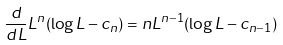<formula> <loc_0><loc_0><loc_500><loc_500>\frac { d } { d L } L ^ { n } ( \log L - c _ { n } ) = n L ^ { n - 1 } ( \log L - c _ { n - 1 } )</formula> 